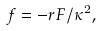Convert formula to latex. <formula><loc_0><loc_0><loc_500><loc_500>f = - r F / \kappa ^ { 2 } ,</formula> 